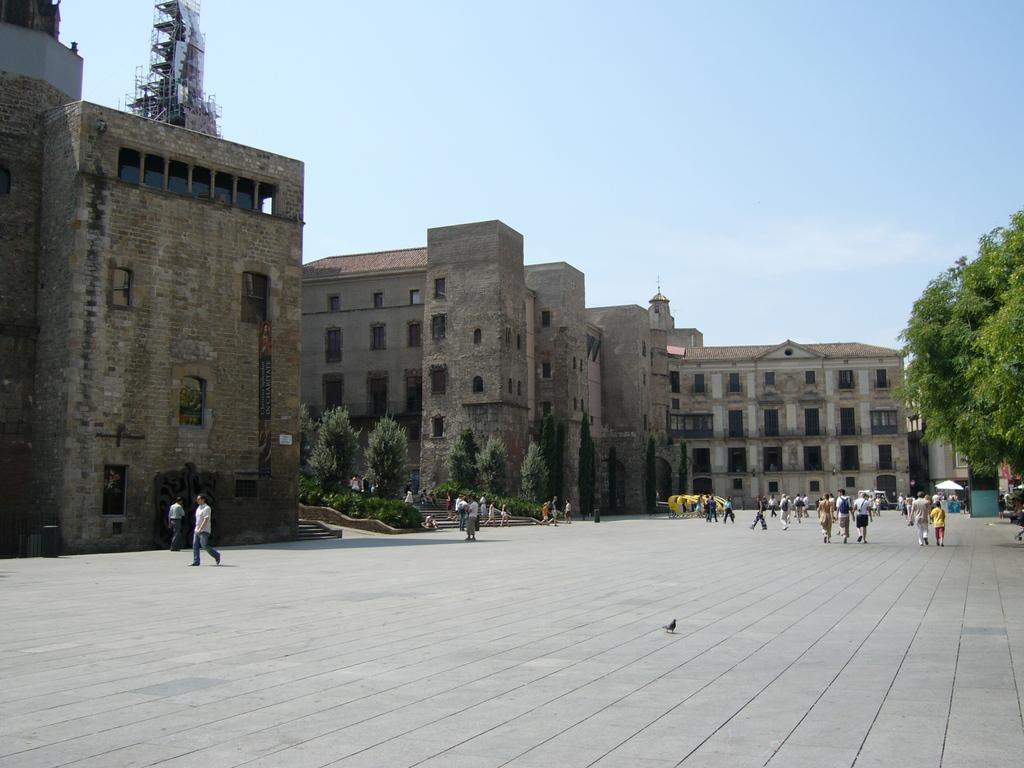In one or two sentences, can you explain what this image depicts? In this picture I can observe some people walking on the land. There are some buildings. On the right side I can observe trees. In the background there is a sky. 